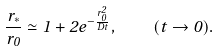<formula> <loc_0><loc_0><loc_500><loc_500>\frac { r _ { * } } { r _ { 0 } } \simeq 1 + 2 e ^ { - \frac { r _ { 0 } ^ { 2 } } { D t } } , \quad ( t \rightarrow 0 ) .</formula> 